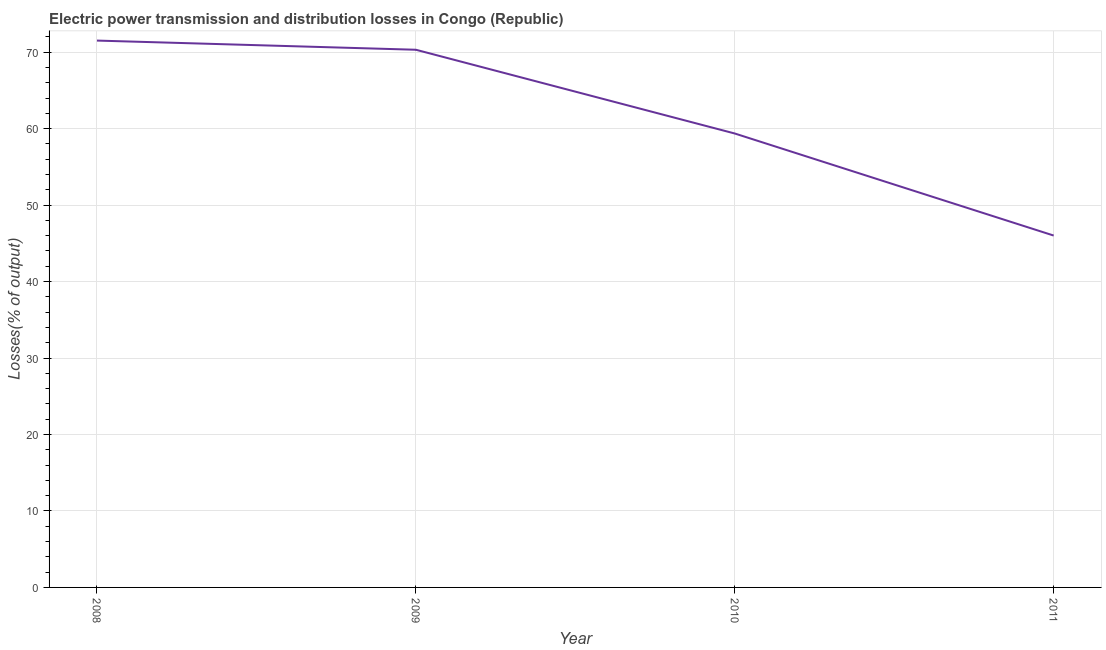What is the electric power transmission and distribution losses in 2009?
Offer a very short reply. 70.32. Across all years, what is the maximum electric power transmission and distribution losses?
Offer a very short reply. 71.52. Across all years, what is the minimum electric power transmission and distribution losses?
Keep it short and to the point. 46.02. In which year was the electric power transmission and distribution losses maximum?
Ensure brevity in your answer.  2008. In which year was the electric power transmission and distribution losses minimum?
Your answer should be compact. 2011. What is the sum of the electric power transmission and distribution losses?
Make the answer very short. 247.21. What is the difference between the electric power transmission and distribution losses in 2008 and 2011?
Give a very brief answer. 25.5. What is the average electric power transmission and distribution losses per year?
Keep it short and to the point. 61.8. What is the median electric power transmission and distribution losses?
Offer a terse response. 64.84. In how many years, is the electric power transmission and distribution losses greater than 16 %?
Offer a terse response. 4. Do a majority of the years between 2010 and 2011 (inclusive) have electric power transmission and distribution losses greater than 38 %?
Offer a very short reply. Yes. What is the ratio of the electric power transmission and distribution losses in 2010 to that in 2011?
Keep it short and to the point. 1.29. Is the difference between the electric power transmission and distribution losses in 2009 and 2010 greater than the difference between any two years?
Offer a very short reply. No. What is the difference between the highest and the second highest electric power transmission and distribution losses?
Make the answer very short. 1.2. Is the sum of the electric power transmission and distribution losses in 2009 and 2010 greater than the maximum electric power transmission and distribution losses across all years?
Keep it short and to the point. Yes. What is the difference between the highest and the lowest electric power transmission and distribution losses?
Provide a short and direct response. 25.5. In how many years, is the electric power transmission and distribution losses greater than the average electric power transmission and distribution losses taken over all years?
Provide a short and direct response. 2. How many lines are there?
Your answer should be very brief. 1. What is the difference between two consecutive major ticks on the Y-axis?
Offer a very short reply. 10. Does the graph contain any zero values?
Provide a short and direct response. No. Does the graph contain grids?
Keep it short and to the point. Yes. What is the title of the graph?
Your answer should be very brief. Electric power transmission and distribution losses in Congo (Republic). What is the label or title of the Y-axis?
Keep it short and to the point. Losses(% of output). What is the Losses(% of output) of 2008?
Keep it short and to the point. 71.52. What is the Losses(% of output) of 2009?
Provide a succinct answer. 70.32. What is the Losses(% of output) in 2010?
Offer a terse response. 59.36. What is the Losses(% of output) in 2011?
Make the answer very short. 46.02. What is the difference between the Losses(% of output) in 2008 and 2009?
Your answer should be very brief. 1.2. What is the difference between the Losses(% of output) in 2008 and 2010?
Make the answer very short. 12.15. What is the difference between the Losses(% of output) in 2008 and 2011?
Give a very brief answer. 25.5. What is the difference between the Losses(% of output) in 2009 and 2010?
Offer a terse response. 10.95. What is the difference between the Losses(% of output) in 2009 and 2011?
Offer a terse response. 24.3. What is the difference between the Losses(% of output) in 2010 and 2011?
Your answer should be compact. 13.35. What is the ratio of the Losses(% of output) in 2008 to that in 2010?
Provide a short and direct response. 1.21. What is the ratio of the Losses(% of output) in 2008 to that in 2011?
Make the answer very short. 1.55. What is the ratio of the Losses(% of output) in 2009 to that in 2010?
Keep it short and to the point. 1.18. What is the ratio of the Losses(% of output) in 2009 to that in 2011?
Keep it short and to the point. 1.53. What is the ratio of the Losses(% of output) in 2010 to that in 2011?
Ensure brevity in your answer.  1.29. 